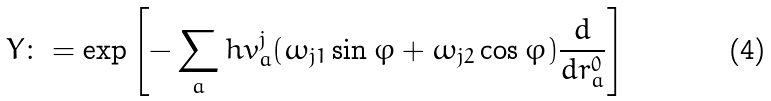<formula> <loc_0><loc_0><loc_500><loc_500>Y \colon = \exp \left [ - \sum _ { a } h v _ { a } ^ { j } ( \omega _ { j 1 } \sin \varphi + \omega _ { j 2 } \cos \varphi ) \frac { d } { d r _ { a } ^ { 0 } } \right ]</formula> 